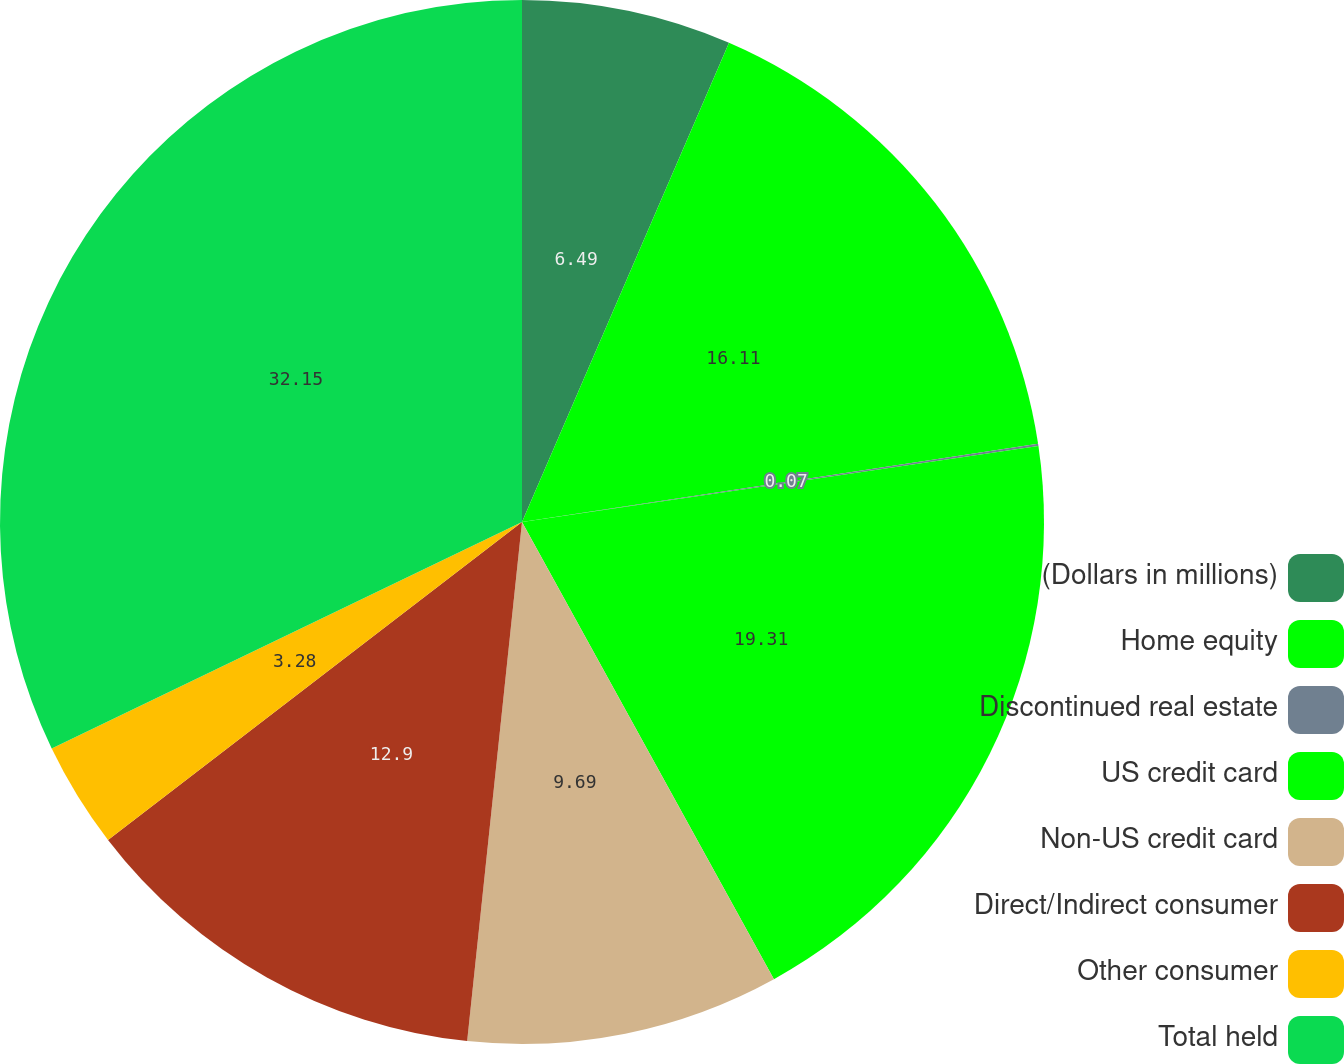<chart> <loc_0><loc_0><loc_500><loc_500><pie_chart><fcel>(Dollars in millions)<fcel>Home equity<fcel>Discontinued real estate<fcel>US credit card<fcel>Non-US credit card<fcel>Direct/Indirect consumer<fcel>Other consumer<fcel>Total held<nl><fcel>6.49%<fcel>16.11%<fcel>0.07%<fcel>19.31%<fcel>9.69%<fcel>12.9%<fcel>3.28%<fcel>32.14%<nl></chart> 